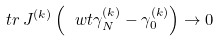<formula> <loc_0><loc_0><loc_500><loc_500>\ t r \, J ^ { ( k ) } \left ( \ w t \gamma ^ { ( k ) } _ { N } - \gamma ^ { ( k ) } _ { 0 } \right ) \to 0</formula> 